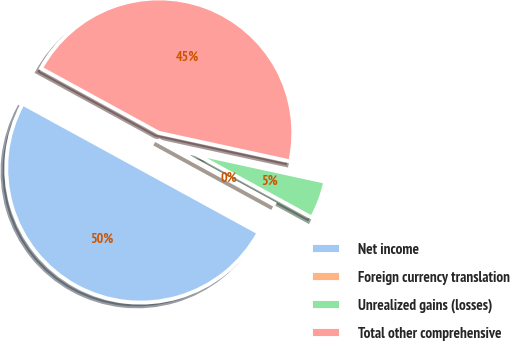Convert chart. <chart><loc_0><loc_0><loc_500><loc_500><pie_chart><fcel>Net income<fcel>Foreign currency translation<fcel>Unrealized gains (losses)<fcel>Total other comprehensive<nl><fcel>50.0%<fcel>0.0%<fcel>4.55%<fcel>45.45%<nl></chart> 